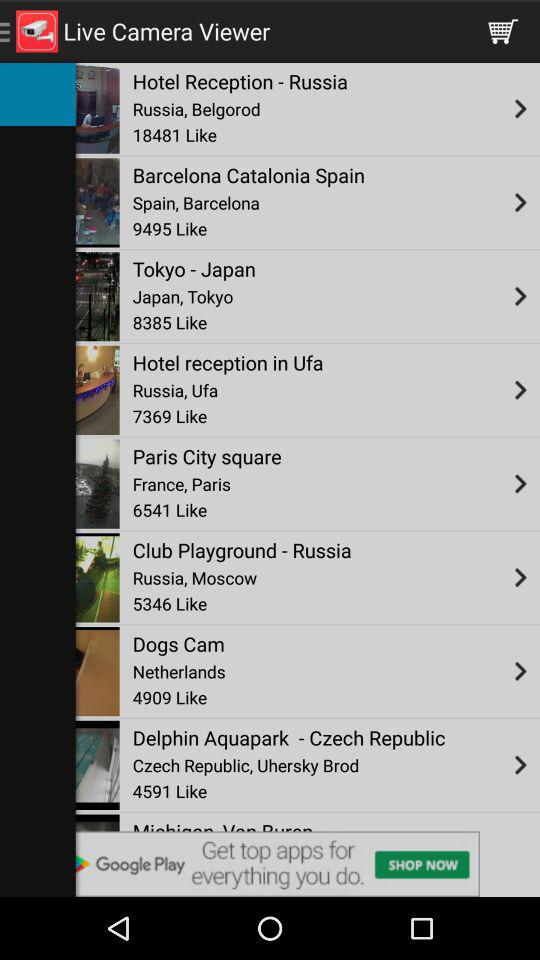To what country does the "Dogs Cam" belong? The "Dogs Cam" belongs to the Netherlands. 